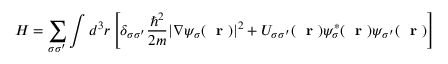Convert formula to latex. <formula><loc_0><loc_0><loc_500><loc_500>H = \sum _ { \sigma \sigma ^ { \prime } } \int d ^ { 3 } r \left [ \delta _ { \sigma \sigma ^ { \prime } } \frac { \hbar { ^ } { 2 } } { 2 m } | \nabla \psi _ { \sigma } ( r ) | ^ { 2 } + U _ { \sigma \sigma ^ { \prime } } ( r ) \psi _ { \sigma } ^ { * } ( r ) \psi _ { \sigma ^ { \prime } } ( r ) \right ]</formula> 